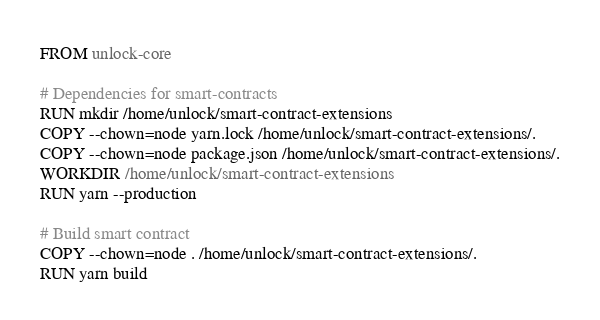Convert code to text. <code><loc_0><loc_0><loc_500><loc_500><_Dockerfile_>FROM unlock-core

# Dependencies for smart-contracts
RUN mkdir /home/unlock/smart-contract-extensions
COPY --chown=node yarn.lock /home/unlock/smart-contract-extensions/.
COPY --chown=node package.json /home/unlock/smart-contract-extensions/.
WORKDIR /home/unlock/smart-contract-extensions
RUN yarn --production

# Build smart contract
COPY --chown=node . /home/unlock/smart-contract-extensions/.
RUN yarn build
</code> 